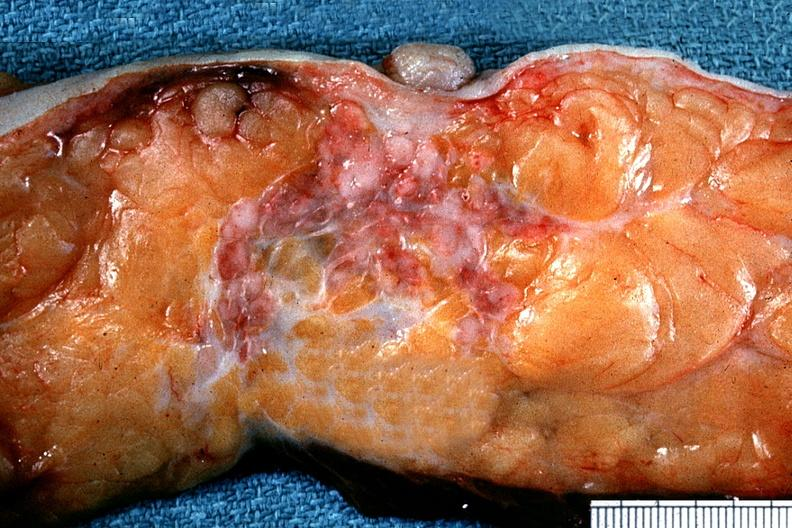where is this area in the body?
Answer the question using a single word or phrase. Breast 